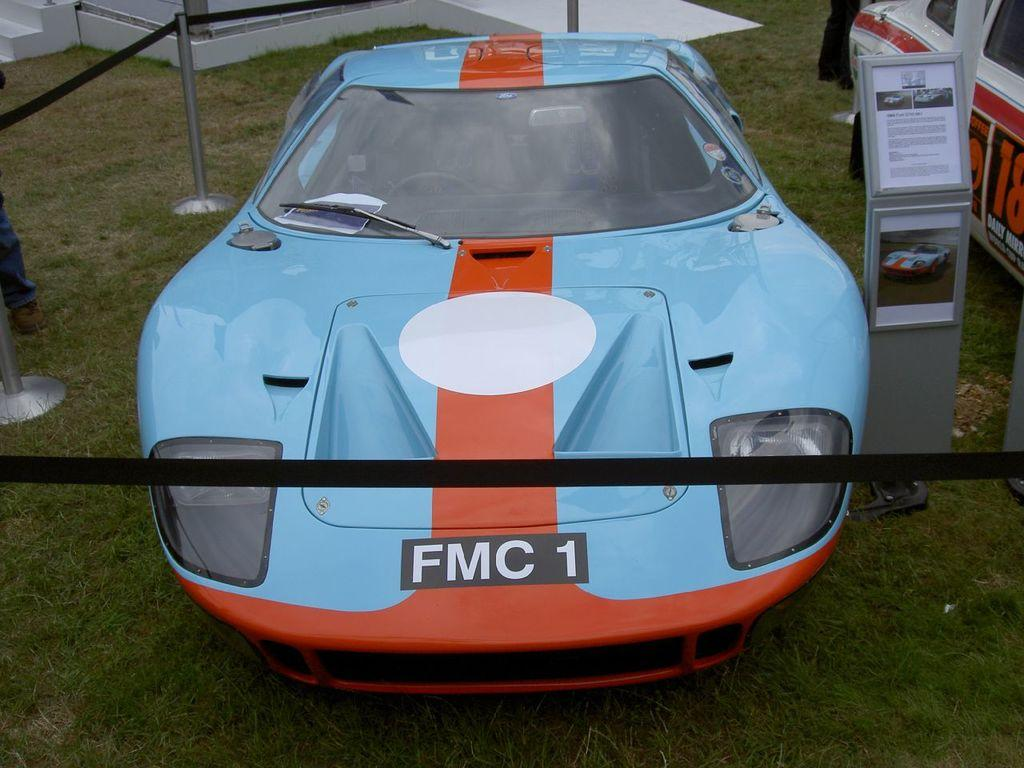What type of vehicles are on the grass in the image? The facts do not specify the type of vehicles, but there are vehicles on the grass in the image. What is used to separate or guide in the image? Rope barriers are present in the image. What is the flat, rectangular object in the image? There is a board in the image. What architectural feature is visible in the image? Stairs are visible in the image. Can you describe a part of a person in the image? A person's leg is observable in the image. What type of glass is being used as a desk in the image? There is no glass desk present in the image; it features vehicles on the grass, rope barriers, a board, stairs, and a person's leg. What kind of ray is emitted from the person's leg in the image? There is no ray emitted from the person's leg in the image. 